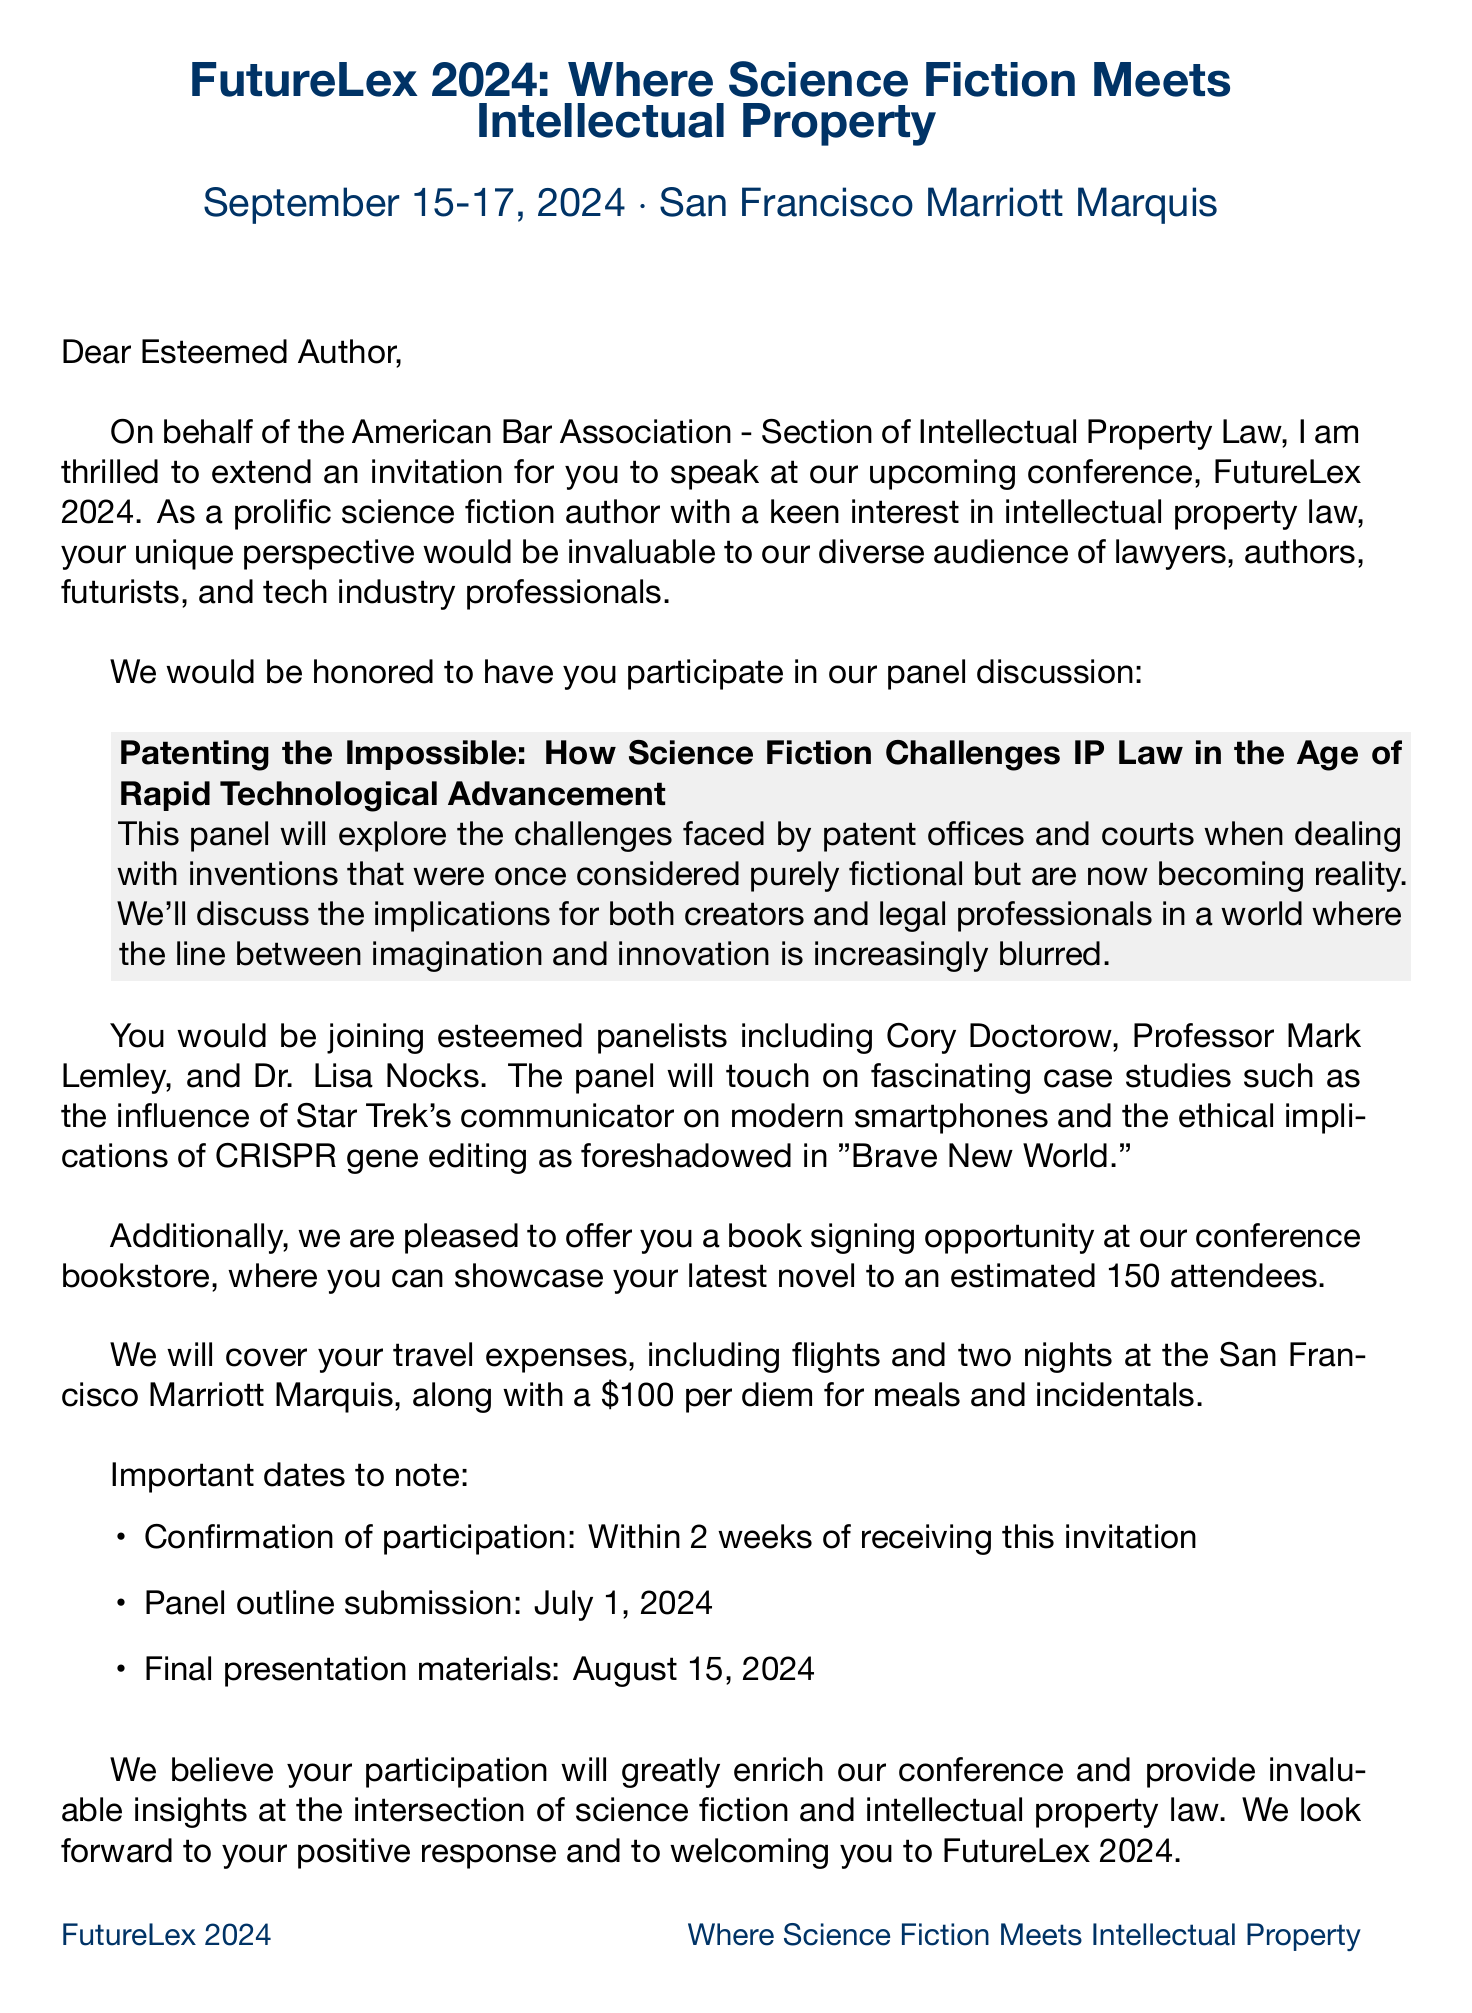What is the name of the conference? The name of the conference is provided in the document as "FutureLex 2024: Where Science Fiction Meets Intellectual Property."
Answer: FutureLex 2024: Where Science Fiction Meets Intellectual Property Who is inviting the author to speak? The document states that Dr. Anita Chen is the Conference Chair extending the invitation.
Answer: Dr. Anita Chen What date does the conference take place? The conference date is mentioned in the document as September 15-17, 2024.
Answer: September 15-17, 2024 What is the proposed panel discussion topic? The document highlights the panel topic as "Patenting the Impossible: How Science Fiction Challenges IP Law in the Age of Rapid Technological Advancement."
Answer: Patenting the Impossible: How Science Fiction Challenges IP Law in the Age of Rapid Technological Advancement How many attendees are expected at the book signing event? The estimated number of attendees for the book signing event is specified as 150.
Answer: 150 What travel expenses are covered by the conference organizers? The document outlines that the conference covers flights, hotel for two nights, and a per diem for meals and incidentals.
Answer: Flights, hotel, and per diem What submission deadlines are outlined in the document? The document lists three important deadlines: confirmation of participation, panel outline submission, and final presentation materials submission.
Answer: Confirmation of participation, panel outline submission, final presentation materials What is the key topic relating to science fiction and IP law discussed in the panel? The document mentions various key topics for discussion, one being "The impact of predictive sci-fi on innovation and R&D strategies in tech companies."
Answer: The impact of predictive sci-fi on innovation and R&D strategies in tech companies What type of professionals are expected to attend the conference? The expected attendees include "Lawyers, authors, futurists, and tech industry professionals."
Answer: Lawyers, authors, futurists, and tech industry professionals 